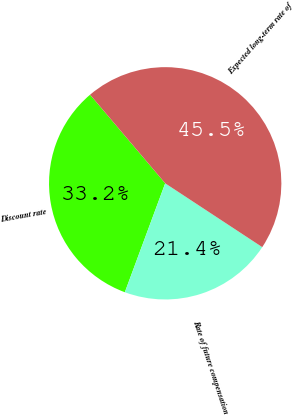Convert chart. <chart><loc_0><loc_0><loc_500><loc_500><pie_chart><fcel>Discount rate<fcel>Rate of future compensation<fcel>Expected long-term rate of<nl><fcel>33.16%<fcel>21.39%<fcel>45.45%<nl></chart> 